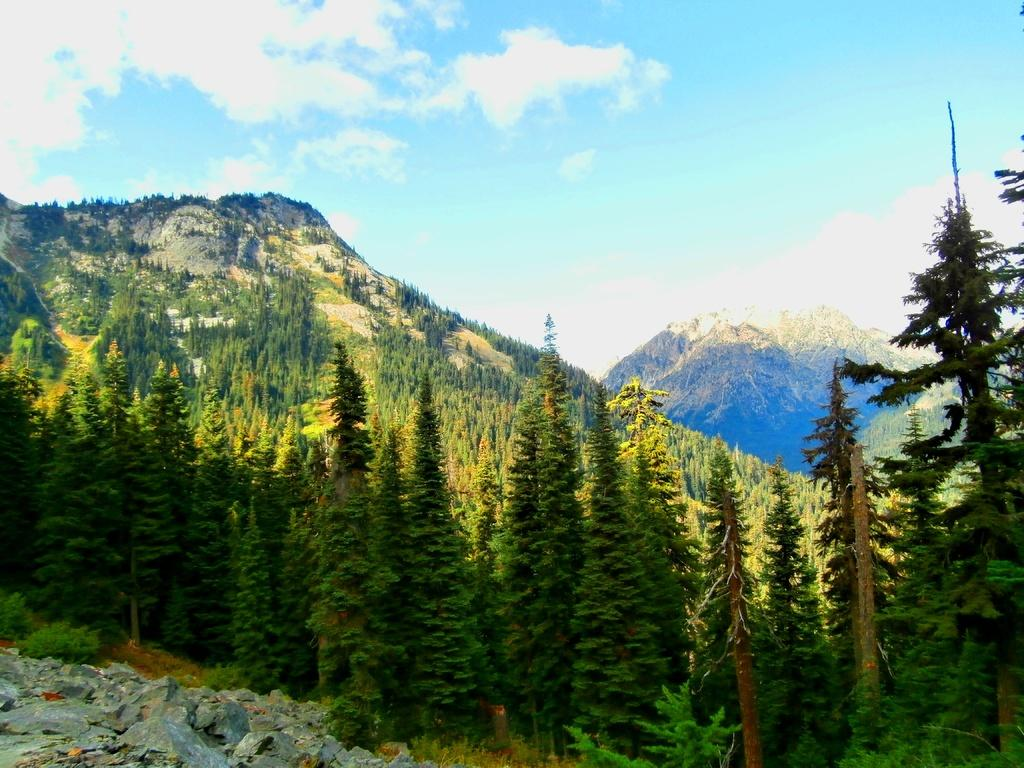What type of objects can be seen in the image? There are stones in the image. What is the setting of the image? There are Christmas trees on a mountain in the image. How would you describe the sky in the image? The sky is blue with clouds in the image. How many cakes are being held by the arm in the image? There are no cakes or arms present in the image. 